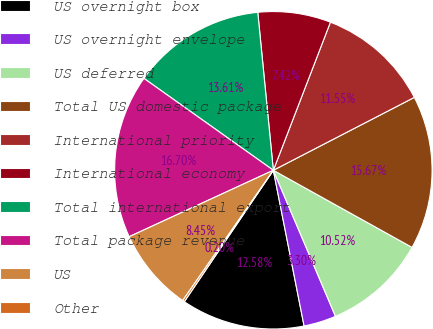<chart> <loc_0><loc_0><loc_500><loc_500><pie_chart><fcel>US overnight box<fcel>US overnight envelope<fcel>US deferred<fcel>Total US domestic package<fcel>International priority<fcel>International economy<fcel>Total international export<fcel>Total package revenue<fcel>US<fcel>Other<nl><fcel>12.58%<fcel>3.3%<fcel>10.52%<fcel>15.67%<fcel>11.55%<fcel>7.42%<fcel>13.61%<fcel>16.7%<fcel>8.45%<fcel>0.2%<nl></chart> 